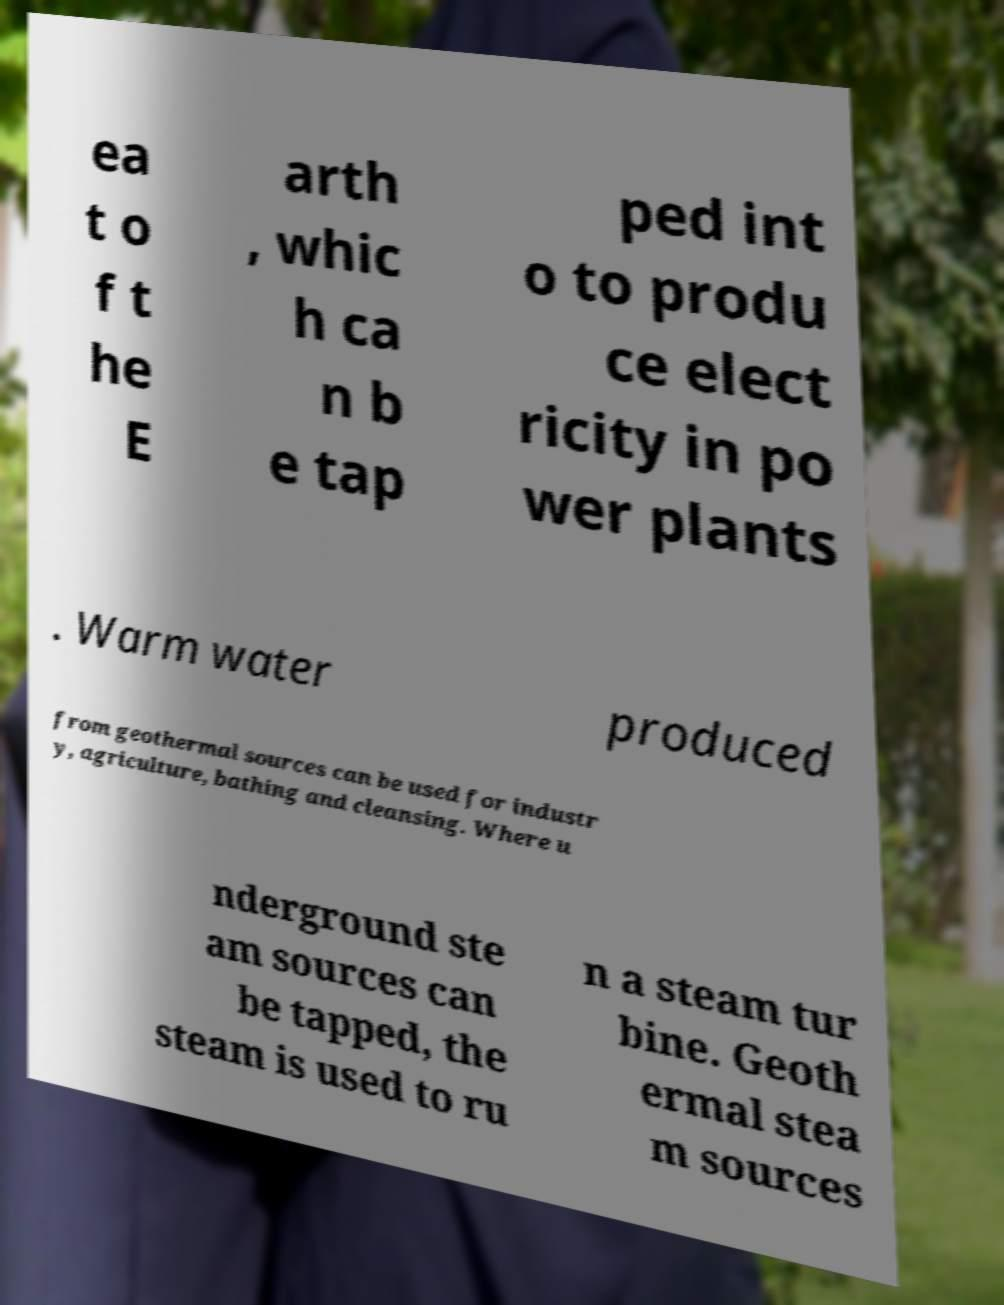Could you assist in decoding the text presented in this image and type it out clearly? ea t o f t he E arth , whic h ca n b e tap ped int o to produ ce elect ricity in po wer plants . Warm water produced from geothermal sources can be used for industr y, agriculture, bathing and cleansing. Where u nderground ste am sources can be tapped, the steam is used to ru n a steam tur bine. Geoth ermal stea m sources 